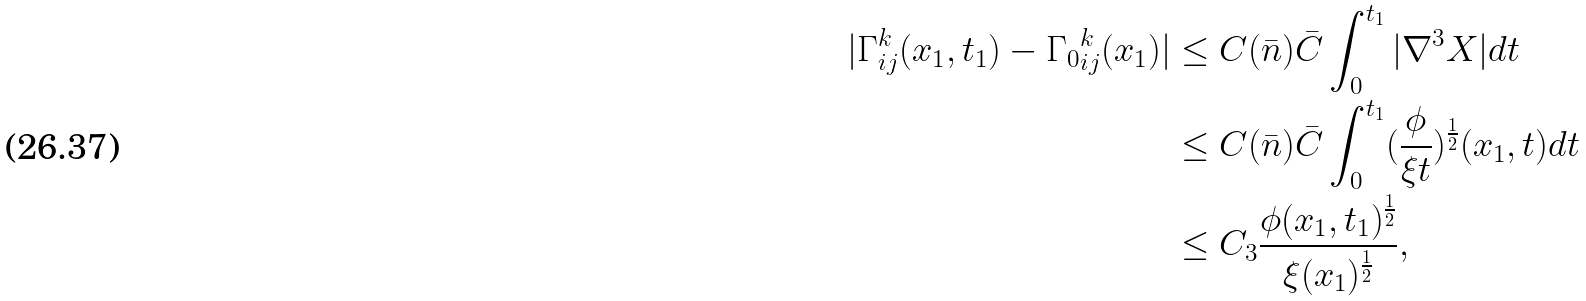<formula> <loc_0><loc_0><loc_500><loc_500>| \Gamma ^ { k } _ { i j } ( x _ { 1 } , t _ { 1 } ) - { \Gamma _ { 0 } } ^ { k } _ { i j } ( x _ { 1 } ) | & \leq C ( \bar { n } ) \bar { C } \int _ { 0 } ^ { t _ { 1 } } | \nabla ^ { 3 } X | d t \\ & \leq C ( \bar { n } ) \bar { C } \int _ { 0 } ^ { t _ { 1 } } ( \frac { \phi } { \xi t } ) ^ { \frac { 1 } { 2 } } ( x _ { 1 } , t ) d t \\ & \leq C _ { 3 } \frac { \phi ( x _ { 1 } , t _ { 1 } ) ^ { \frac { 1 } { 2 } } } { \xi ( x _ { 1 } ) ^ { \frac { 1 } { 2 } } } ,</formula> 